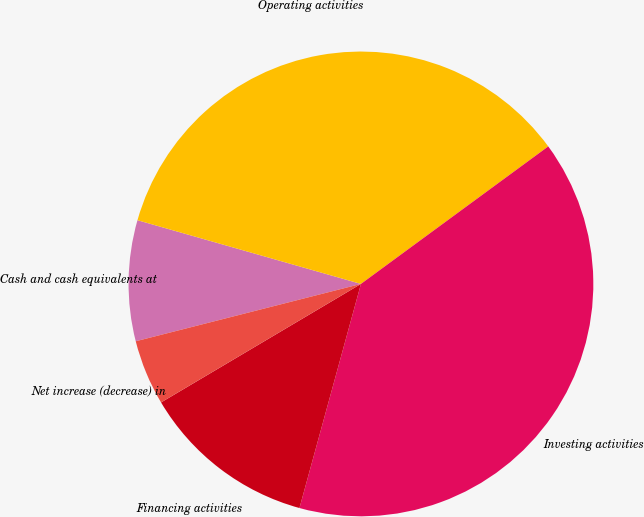Convert chart. <chart><loc_0><loc_0><loc_500><loc_500><pie_chart><fcel>Cash and cash equivalents at<fcel>Operating activities<fcel>Investing activities<fcel>Financing activities<fcel>Net increase (decrease) in<nl><fcel>8.39%<fcel>35.5%<fcel>39.34%<fcel>12.22%<fcel>4.55%<nl></chart> 